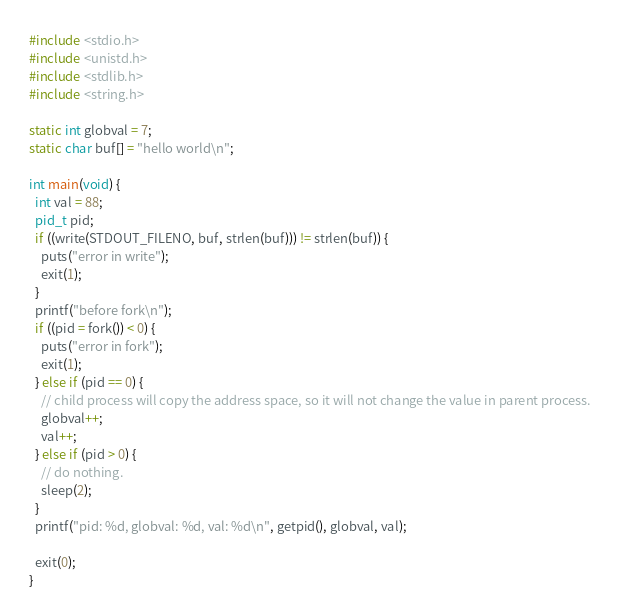Convert code to text. <code><loc_0><loc_0><loc_500><loc_500><_C_>#include <stdio.h>
#include <unistd.h>
#include <stdlib.h>
#include <string.h>

static int globval = 7;
static char buf[] = "hello world\n";

int main(void) {
  int val = 88;
  pid_t pid;
  if ((write(STDOUT_FILENO, buf, strlen(buf))) != strlen(buf)) {
    puts("error in write");
    exit(1);
  }
  printf("before fork\n");
  if ((pid = fork()) < 0) {
    puts("error in fork");
    exit(1);
  } else if (pid == 0) {
    // child process will copy the address space, so it will not change the value in parent process.
    globval++;
    val++;
  } else if (pid > 0) {
    // do nothing.
    sleep(2);
  }
  printf("pid: %d, globval: %d, val: %d\n", getpid(), globval, val);

  exit(0);
}</code> 